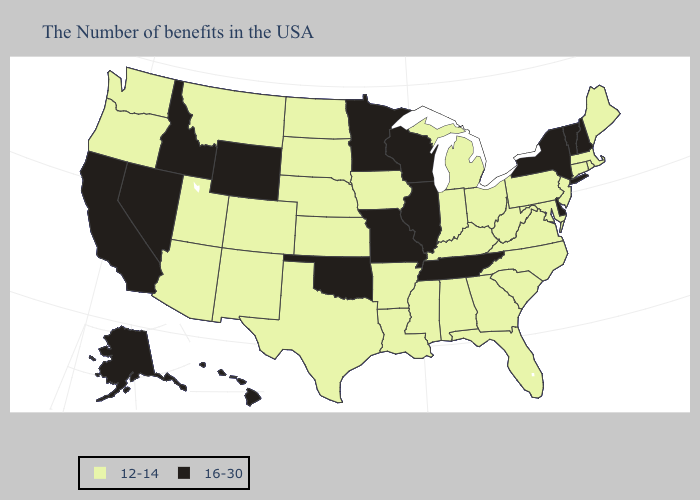What is the lowest value in states that border Washington?
Be succinct. 12-14. Which states have the highest value in the USA?
Give a very brief answer. New Hampshire, Vermont, New York, Delaware, Tennessee, Wisconsin, Illinois, Missouri, Minnesota, Oklahoma, Wyoming, Idaho, Nevada, California, Alaska, Hawaii. Does Kentucky have the same value as Oklahoma?
Give a very brief answer. No. Name the states that have a value in the range 16-30?
Keep it brief. New Hampshire, Vermont, New York, Delaware, Tennessee, Wisconsin, Illinois, Missouri, Minnesota, Oklahoma, Wyoming, Idaho, Nevada, California, Alaska, Hawaii. Among the states that border Nebraska , does Kansas have the lowest value?
Keep it brief. Yes. Name the states that have a value in the range 16-30?
Short answer required. New Hampshire, Vermont, New York, Delaware, Tennessee, Wisconsin, Illinois, Missouri, Minnesota, Oklahoma, Wyoming, Idaho, Nevada, California, Alaska, Hawaii. Name the states that have a value in the range 16-30?
Concise answer only. New Hampshire, Vermont, New York, Delaware, Tennessee, Wisconsin, Illinois, Missouri, Minnesota, Oklahoma, Wyoming, Idaho, Nevada, California, Alaska, Hawaii. Among the states that border New Jersey , which have the highest value?
Quick response, please. New York, Delaware. What is the highest value in states that border Wisconsin?
Keep it brief. 16-30. What is the value of Delaware?
Short answer required. 16-30. What is the highest value in the USA?
Short answer required. 16-30. Name the states that have a value in the range 16-30?
Answer briefly. New Hampshire, Vermont, New York, Delaware, Tennessee, Wisconsin, Illinois, Missouri, Minnesota, Oklahoma, Wyoming, Idaho, Nevada, California, Alaska, Hawaii. What is the value of Nebraska?
Be succinct. 12-14. Name the states that have a value in the range 12-14?
Concise answer only. Maine, Massachusetts, Rhode Island, Connecticut, New Jersey, Maryland, Pennsylvania, Virginia, North Carolina, South Carolina, West Virginia, Ohio, Florida, Georgia, Michigan, Kentucky, Indiana, Alabama, Mississippi, Louisiana, Arkansas, Iowa, Kansas, Nebraska, Texas, South Dakota, North Dakota, Colorado, New Mexico, Utah, Montana, Arizona, Washington, Oregon. Name the states that have a value in the range 16-30?
Keep it brief. New Hampshire, Vermont, New York, Delaware, Tennessee, Wisconsin, Illinois, Missouri, Minnesota, Oklahoma, Wyoming, Idaho, Nevada, California, Alaska, Hawaii. 